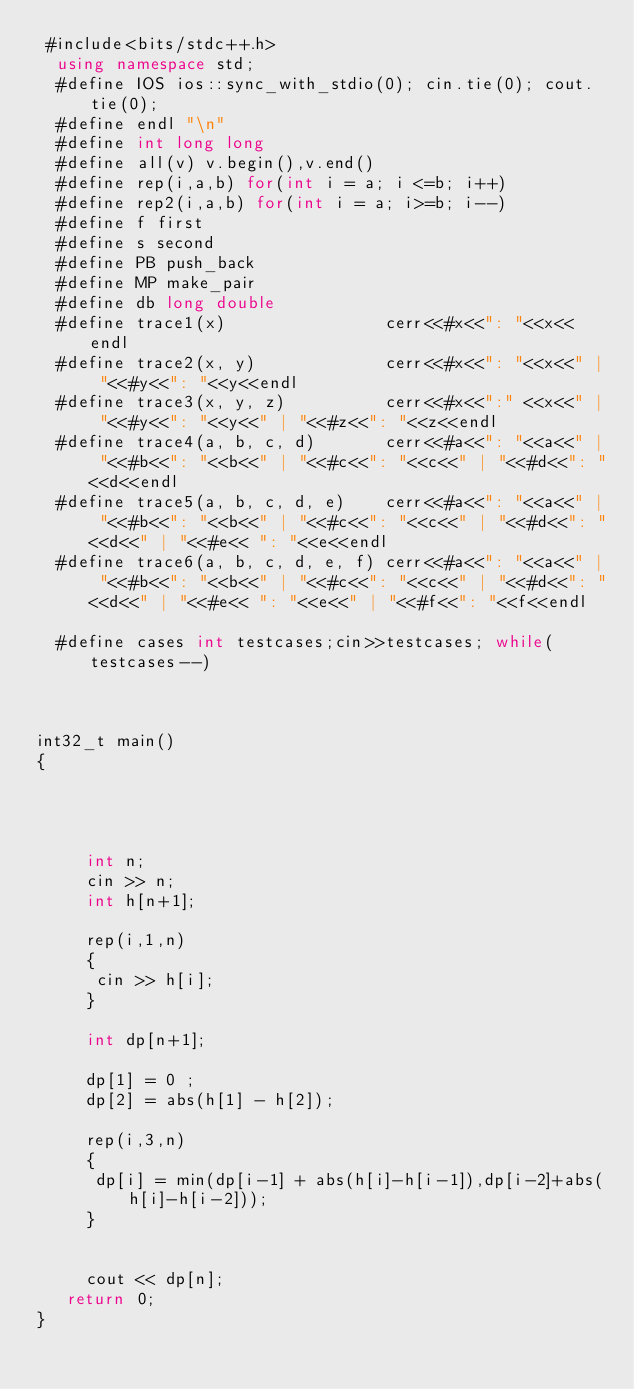Convert code to text. <code><loc_0><loc_0><loc_500><loc_500><_C++_> #include<bits/stdc++.h>
  using namespace std;
  #define IOS ios::sync_with_stdio(0); cin.tie(0); cout.tie(0);
  #define endl "\n"
  #define int long long
  #define all(v) v.begin(),v.end()
  #define rep(i,a,b) for(int i = a; i <=b; i++)
  #define rep2(i,a,b) for(int i = a; i>=b; i--)
  #define f first
  #define s second
  #define PB push_back
  #define MP make_pair
  #define db long double
  #define trace1(x)                cerr<<#x<<": "<<x<<endl
  #define trace2(x, y)             cerr<<#x<<": "<<x<<" | "<<#y<<": "<<y<<endl
  #define trace3(x, y, z)          cerr<<#x<<":" <<x<<" | "<<#y<<": "<<y<<" | "<<#z<<": "<<z<<endl
  #define trace4(a, b, c, d)       cerr<<#a<<": "<<a<<" | "<<#b<<": "<<b<<" | "<<#c<<": "<<c<<" | "<<#d<<": "<<d<<endl
  #define trace5(a, b, c, d, e)    cerr<<#a<<": "<<a<<" | "<<#b<<": "<<b<<" | "<<#c<<": "<<c<<" | "<<#d<<": "<<d<<" | "<<#e<< ": "<<e<<endl
  #define trace6(a, b, c, d, e, f) cerr<<#a<<": "<<a<<" | "<<#b<<": "<<b<<" | "<<#c<<": "<<c<<" | "<<#d<<": "<<d<<" | "<<#e<< ": "<<e<<" | "<<#f<<": "<<f<<endl

  #define cases int testcases;cin>>testcases; while(testcases--)
      


int32_t main()
{
       


    
     int n;
     cin >> n;
     int h[n+1];

     rep(i,1,n)
     {
      cin >> h[i];
     }

     int dp[n+1];

     dp[1] = 0 ;
     dp[2] = abs(h[1] - h[2]);

     rep(i,3,n)
     {
      dp[i] = min(dp[i-1] + abs(h[i]-h[i-1]),dp[i-2]+abs(h[i]-h[i-2]));
     }


     cout << dp[n];
   return 0;
} </code> 